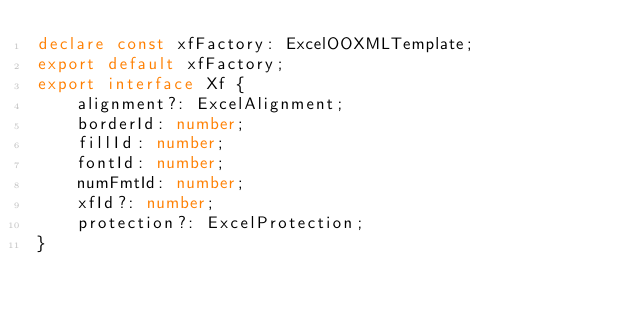<code> <loc_0><loc_0><loc_500><loc_500><_TypeScript_>declare const xfFactory: ExcelOOXMLTemplate;
export default xfFactory;
export interface Xf {
    alignment?: ExcelAlignment;
    borderId: number;
    fillId: number;
    fontId: number;
    numFmtId: number;
    xfId?: number;
    protection?: ExcelProtection;
}
</code> 